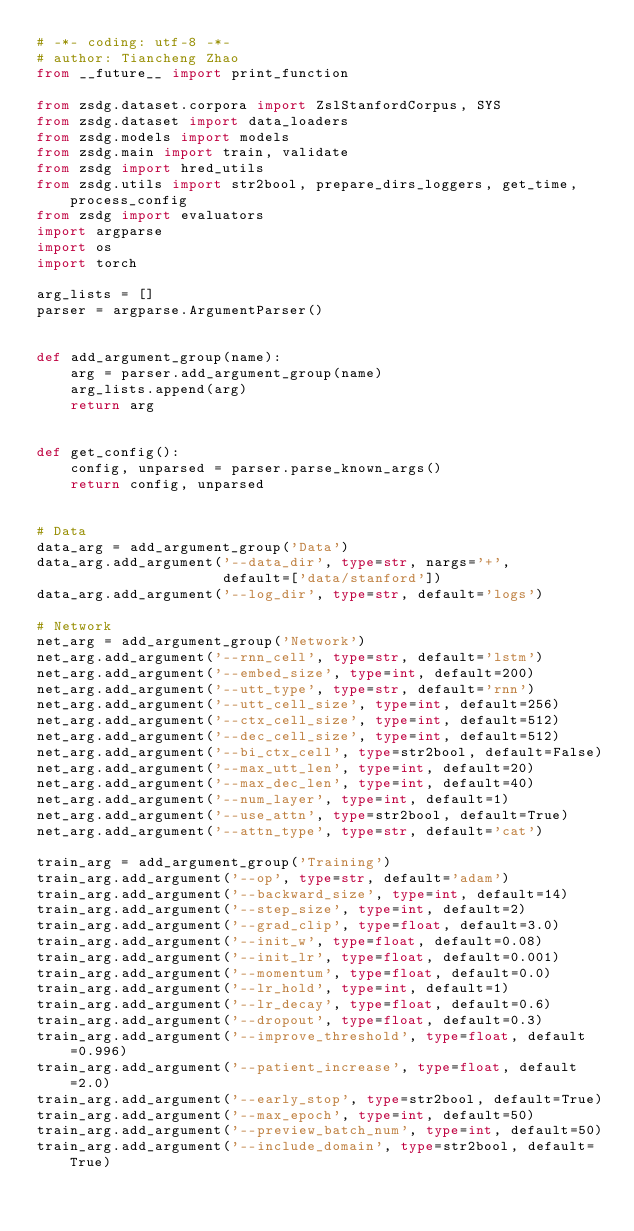<code> <loc_0><loc_0><loc_500><loc_500><_Python_># -*- coding: utf-8 -*-
# author: Tiancheng Zhao
from __future__ import print_function

from zsdg.dataset.corpora import ZslStanfordCorpus, SYS
from zsdg.dataset import data_loaders
from zsdg.models import models
from zsdg.main import train, validate
from zsdg import hred_utils
from zsdg.utils import str2bool, prepare_dirs_loggers, get_time, process_config
from zsdg import evaluators
import argparse
import os
import torch

arg_lists = []
parser = argparse.ArgumentParser()


def add_argument_group(name):
    arg = parser.add_argument_group(name)
    arg_lists.append(arg)
    return arg


def get_config():
    config, unparsed = parser.parse_known_args()
    return config, unparsed


# Data
data_arg = add_argument_group('Data')
data_arg.add_argument('--data_dir', type=str, nargs='+',
                      default=['data/stanford'])
data_arg.add_argument('--log_dir', type=str, default='logs')

# Network
net_arg = add_argument_group('Network')
net_arg.add_argument('--rnn_cell', type=str, default='lstm')
net_arg.add_argument('--embed_size', type=int, default=200)
net_arg.add_argument('--utt_type', type=str, default='rnn')
net_arg.add_argument('--utt_cell_size', type=int, default=256)
net_arg.add_argument('--ctx_cell_size', type=int, default=512)
net_arg.add_argument('--dec_cell_size', type=int, default=512)
net_arg.add_argument('--bi_ctx_cell', type=str2bool, default=False)
net_arg.add_argument('--max_utt_len', type=int, default=20)
net_arg.add_argument('--max_dec_len', type=int, default=40)
net_arg.add_argument('--num_layer', type=int, default=1)
net_arg.add_argument('--use_attn', type=str2bool, default=True)
net_arg.add_argument('--attn_type', type=str, default='cat')

train_arg = add_argument_group('Training')
train_arg.add_argument('--op', type=str, default='adam')
train_arg.add_argument('--backward_size', type=int, default=14)
train_arg.add_argument('--step_size', type=int, default=2)
train_arg.add_argument('--grad_clip', type=float, default=3.0)
train_arg.add_argument('--init_w', type=float, default=0.08)
train_arg.add_argument('--init_lr', type=float, default=0.001)
train_arg.add_argument('--momentum', type=float, default=0.0)
train_arg.add_argument('--lr_hold', type=int, default=1)
train_arg.add_argument('--lr_decay', type=float, default=0.6)
train_arg.add_argument('--dropout', type=float, default=0.3)
train_arg.add_argument('--improve_threshold', type=float, default=0.996)
train_arg.add_argument('--patient_increase', type=float, default=2.0)
train_arg.add_argument('--early_stop', type=str2bool, default=True)
train_arg.add_argument('--max_epoch', type=int, default=50)
train_arg.add_argument('--preview_batch_num', type=int, default=50)
train_arg.add_argument('--include_domain', type=str2bool, default=True)</code> 